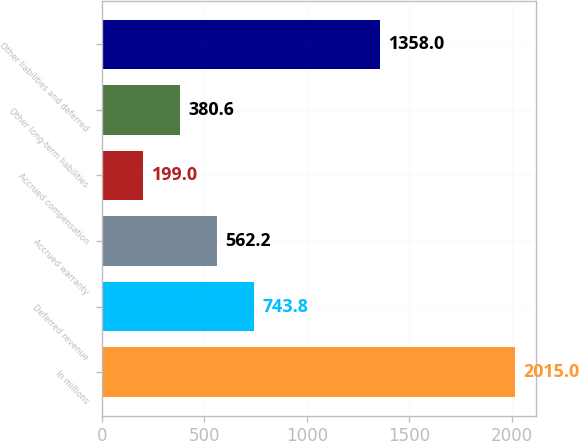<chart> <loc_0><loc_0><loc_500><loc_500><bar_chart><fcel>In millions<fcel>Deferred revenue<fcel>Accrued warranty<fcel>Accrued compensation<fcel>Other long-term liabilities<fcel>Other liabilities and deferred<nl><fcel>2015<fcel>743.8<fcel>562.2<fcel>199<fcel>380.6<fcel>1358<nl></chart> 